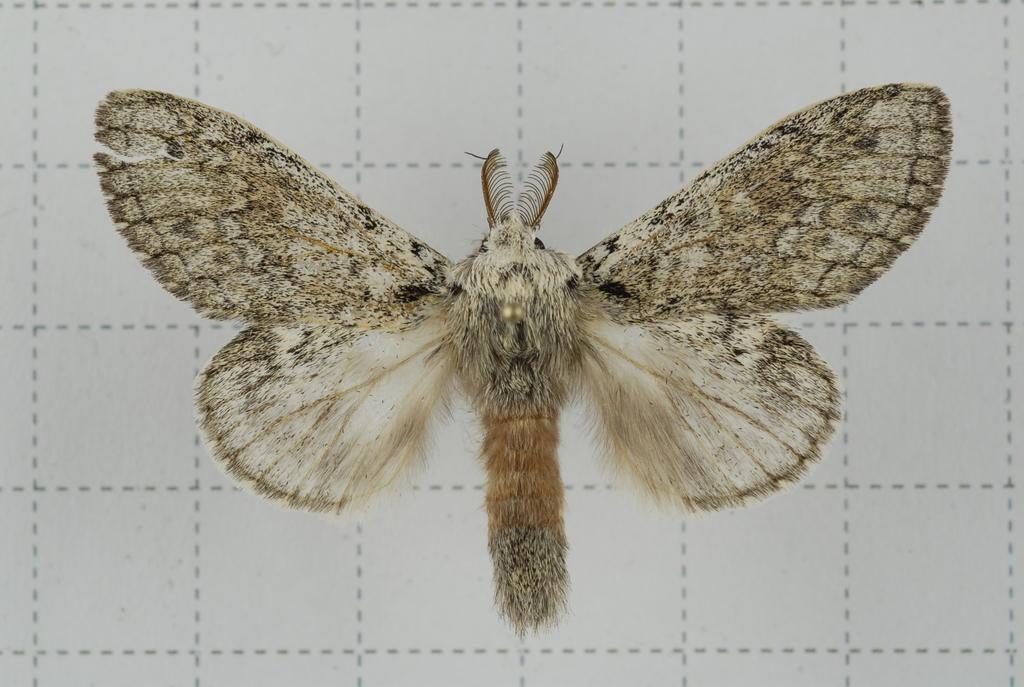Can you describe this image briefly? In this image, we can see a butterfly. The background is white with dotted lines. 